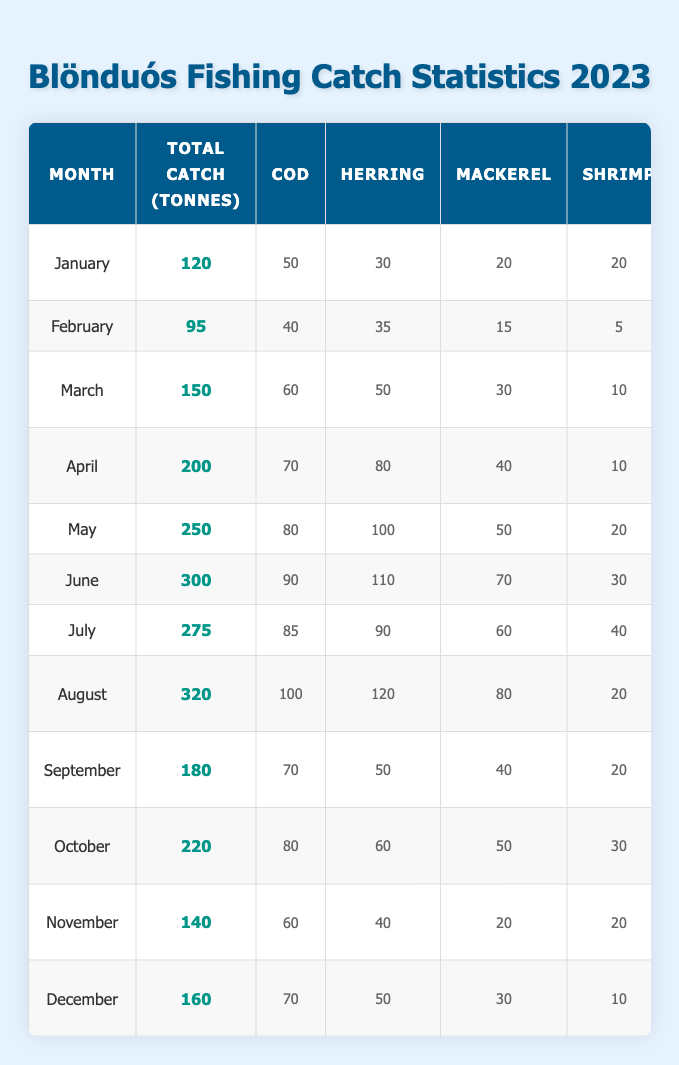What was the total fish catch in August? In the table, the total catch for August is clearly stated as 320 tonnes.
Answer: 320 tonnes Which month had the highest catch of shrimp? Looking at the species column for shrimp, August has the highest catch of 20 tonnes, while other months have lower catches.
Answer: August What is the total catch for the month of April? The table indicates that the total catch for April is 200 tonnes.
Answer: 200 tonnes Which species had the highest catch in June? In June, the catch values are: Cod (90), Herring (110), Mackerel (70), and Shrimp (30). Herring had the highest catch at 110 tonnes.
Answer: Herring What is the average total catch of fish for the first quarter (January, February, March)? The total catches for the first quarter are: January (120), February (95), and March (150). Summing these gives 120 + 95 + 150 = 365. Dividing by 3 gives an average of 365 / 3 = 121.67.
Answer: 121.67 tonnes Which month had the least fishing hours? The fishing hours are listed as follows: January (160), February (140), March (180), April (200), May (220), June (240), July (230), August (250), September (190), October (210), November (170), December (180). February has the least at 140 hours.
Answer: February Was the total catch in December greater than 150 tonnes? The total catch for December is 160 tonnes, which is greater than 150 tonnes. Thus the answer is yes.
Answer: Yes Which fishing ship had the most fishing hours in the month of May? The table lists May's top fishing ship as Lóni NH with 220 fishing hours.
Answer: Lóni NH How much more total fish was caught in July compared to September? The total catch for July is 275 tonnes and for September, it is 180 tonnes. The difference is 275 - 180 = 95 tonnes.
Answer: 95 tonnes Which month had a total fish catch closer to 200 tonnes, October or November? Total catch for October is 220 tonnes and for November, it is 140 tonnes. The difference from 200 is less for October (20) than November (60), so October is closer.
Answer: October 